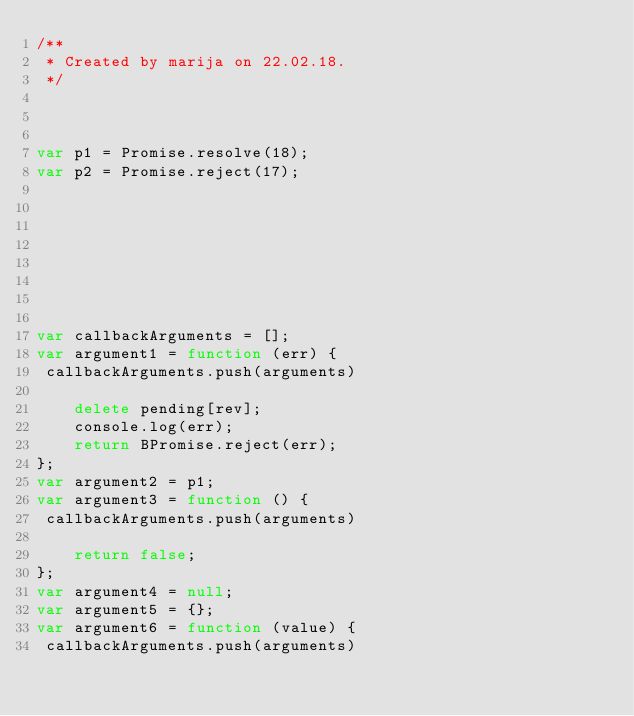Convert code to text. <code><loc_0><loc_0><loc_500><loc_500><_JavaScript_>/**
 * Created by marija on 22.02.18.
 */



var p1 = Promise.resolve(18);
var p2 = Promise.reject(17);








var callbackArguments = [];
var argument1 = function (err) {
 callbackArguments.push(arguments) 

    delete pending[rev];
    console.log(err);
    return BPromise.reject(err);
};
var argument2 = p1;
var argument3 = function () {
 callbackArguments.push(arguments) 

    return false;
};
var argument4 = null;
var argument5 = {};
var argument6 = function (value) {
 callbackArguments.push(arguments) 
</code> 